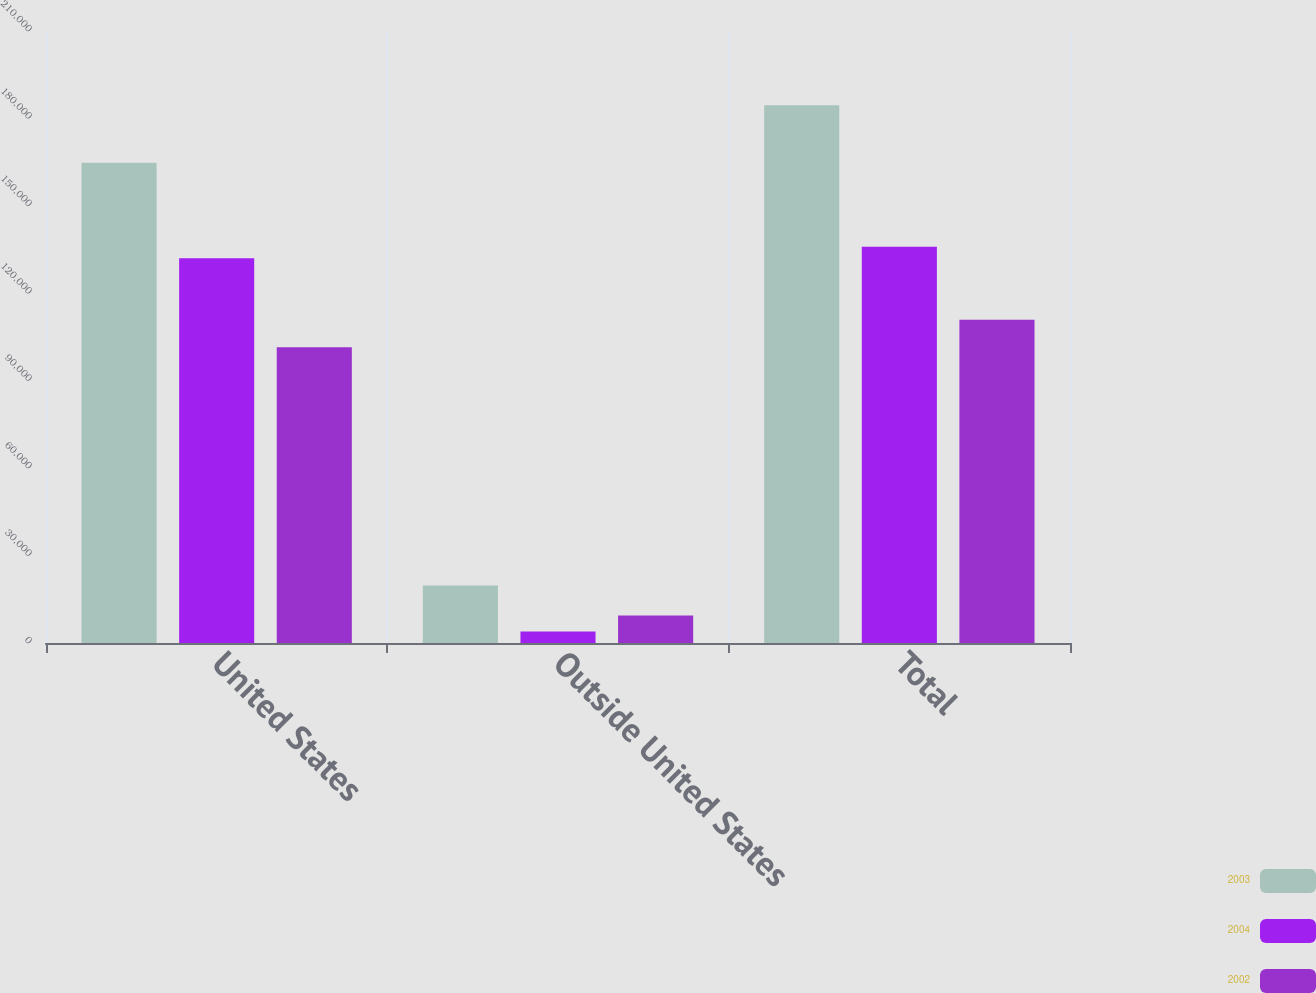<chart> <loc_0><loc_0><loc_500><loc_500><stacked_bar_chart><ecel><fcel>United States<fcel>Outside United States<fcel>Total<nl><fcel>2003<fcel>164784<fcel>19764<fcel>184548<nl><fcel>2004<fcel>132056<fcel>3936<fcel>135992<nl><fcel>2002<fcel>101454<fcel>9429<fcel>110883<nl></chart> 